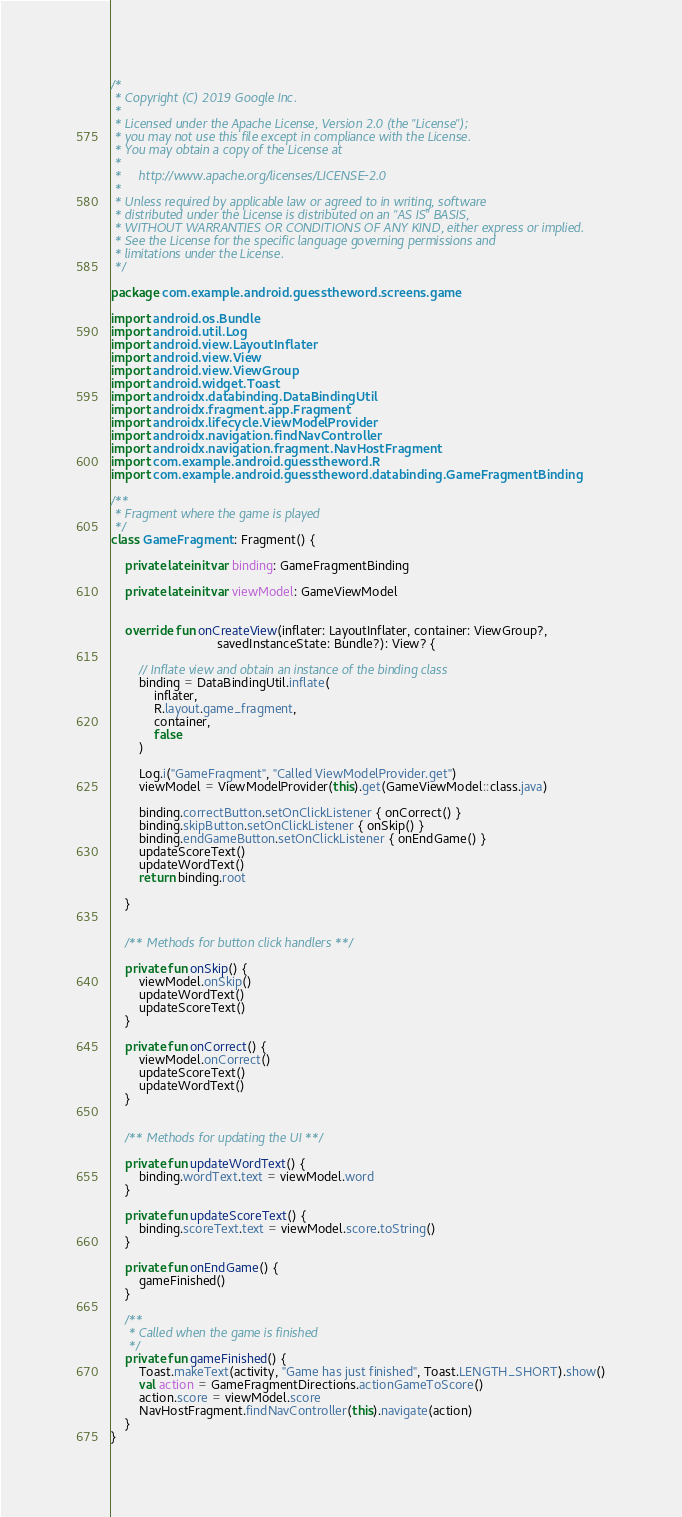Convert code to text. <code><loc_0><loc_0><loc_500><loc_500><_Kotlin_>/*
 * Copyright (C) 2019 Google Inc.
 *
 * Licensed under the Apache License, Version 2.0 (the "License");
 * you may not use this file except in compliance with the License.
 * You may obtain a copy of the License at
 *
 *     http://www.apache.org/licenses/LICENSE-2.0
 *
 * Unless required by applicable law or agreed to in writing, software
 * distributed under the License is distributed on an "AS IS" BASIS,
 * WITHOUT WARRANTIES OR CONDITIONS OF ANY KIND, either express or implied.
 * See the License for the specific language governing permissions and
 * limitations under the License.
 */

package com.example.android.guesstheword.screens.game

import android.os.Bundle
import android.util.Log
import android.view.LayoutInflater
import android.view.View
import android.view.ViewGroup
import android.widget.Toast
import androidx.databinding.DataBindingUtil
import androidx.fragment.app.Fragment
import androidx.lifecycle.ViewModelProvider
import androidx.navigation.findNavController
import androidx.navigation.fragment.NavHostFragment
import com.example.android.guesstheword.R
import com.example.android.guesstheword.databinding.GameFragmentBinding

/**
 * Fragment where the game is played
 */
class GameFragment : Fragment() {

    private lateinit var binding: GameFragmentBinding

    private lateinit var viewModel: GameViewModel


    override fun onCreateView(inflater: LayoutInflater, container: ViewGroup?,
                              savedInstanceState: Bundle?): View? {

        // Inflate view and obtain an instance of the binding class
        binding = DataBindingUtil.inflate(
            inflater,
            R.layout.game_fragment,
            container,
            false
        )

        Log.i("GameFragment", "Called ViewModelProvider.get")
        viewModel = ViewModelProvider(this).get(GameViewModel::class.java)

        binding.correctButton.setOnClickListener { onCorrect() }
        binding.skipButton.setOnClickListener { onSkip() }
        binding.endGameButton.setOnClickListener { onEndGame() }
        updateScoreText()
        updateWordText()
        return binding.root

    }


    /** Methods for button click handlers **/

    private fun onSkip() {
        viewModel.onSkip()
        updateWordText()
        updateScoreText()
    }

    private fun onCorrect() {
        viewModel.onCorrect()
        updateScoreText()
        updateWordText()
    }


    /** Methods for updating the UI **/

    private fun updateWordText() {
        binding.wordText.text = viewModel.word
    }

    private fun updateScoreText() {
        binding.scoreText.text = viewModel.score.toString()
    }

    private fun onEndGame() {
        gameFinished()
    }

    /**
     * Called when the game is finished
     */
    private fun gameFinished() {
        Toast.makeText(activity, "Game has just finished", Toast.LENGTH_SHORT).show()
        val action = GameFragmentDirections.actionGameToScore()
        action.score = viewModel.score
        NavHostFragment.findNavController(this).navigate(action)
    }
}
</code> 